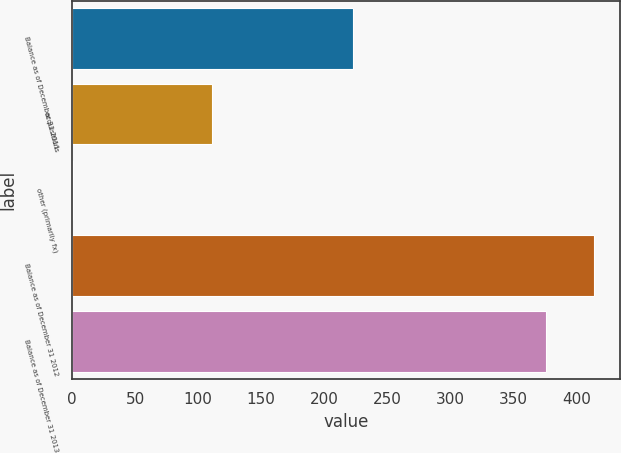Convert chart to OTSL. <chart><loc_0><loc_0><loc_500><loc_500><bar_chart><fcel>Balance as of December 31 2011<fcel>acquisitions<fcel>other (primarily fx)<fcel>Balance as of December 31 2012<fcel>Balance as of December 31 2013<nl><fcel>223<fcel>111<fcel>1<fcel>413.9<fcel>376<nl></chart> 